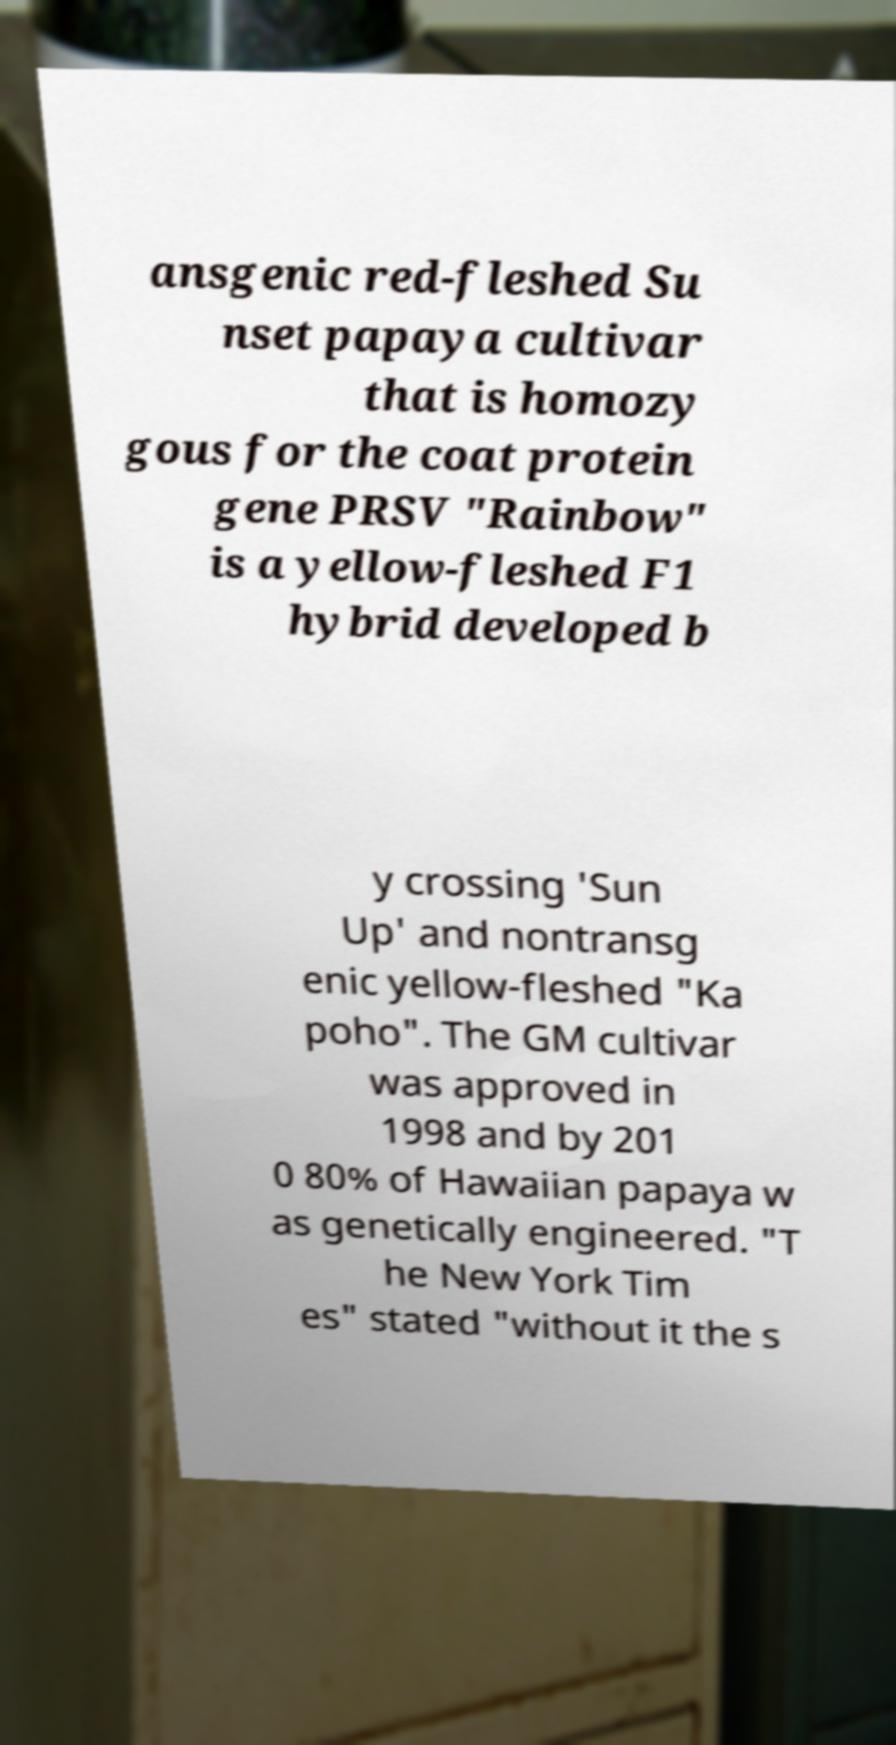Can you read and provide the text displayed in the image?This photo seems to have some interesting text. Can you extract and type it out for me? ansgenic red-fleshed Su nset papaya cultivar that is homozy gous for the coat protein gene PRSV "Rainbow" is a yellow-fleshed F1 hybrid developed b y crossing 'Sun Up' and nontransg enic yellow-fleshed "Ka poho". The GM cultivar was approved in 1998 and by 201 0 80% of Hawaiian papaya w as genetically engineered. "T he New York Tim es" stated "without it the s 